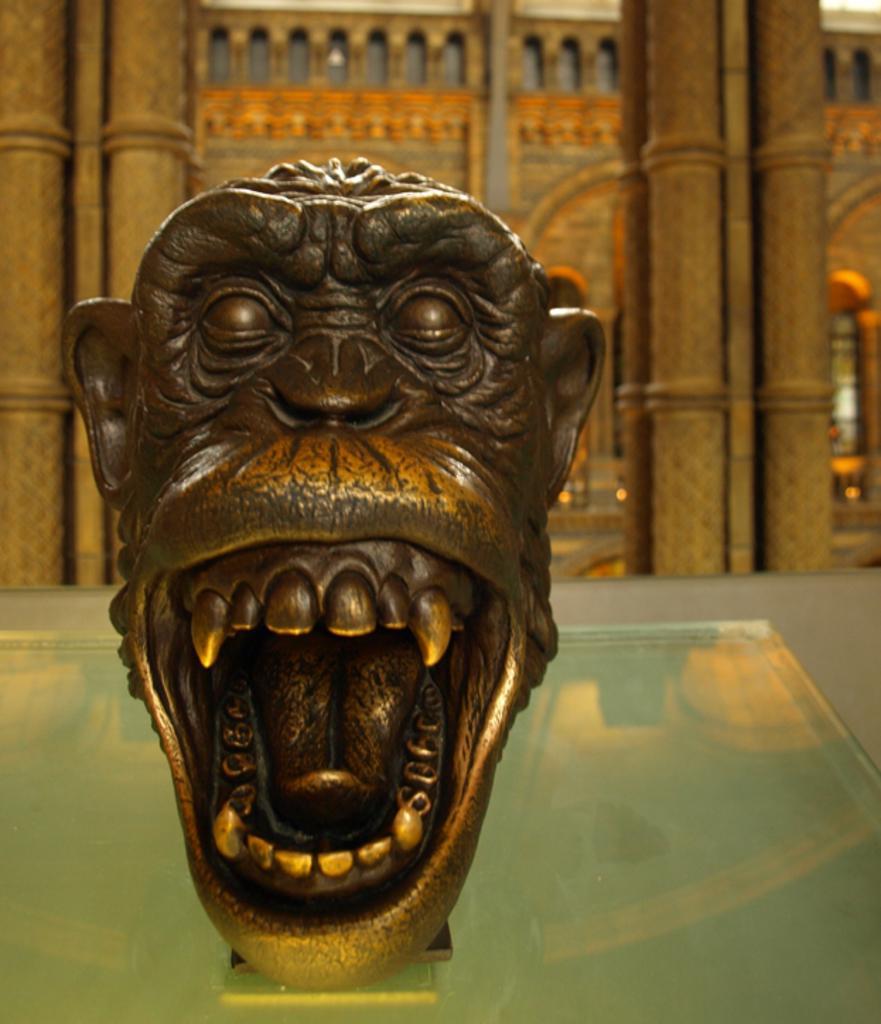Could you give a brief overview of what you see in this image? Here we can see a sculpture on a glass platform. In the background we can see pillars and wall. 